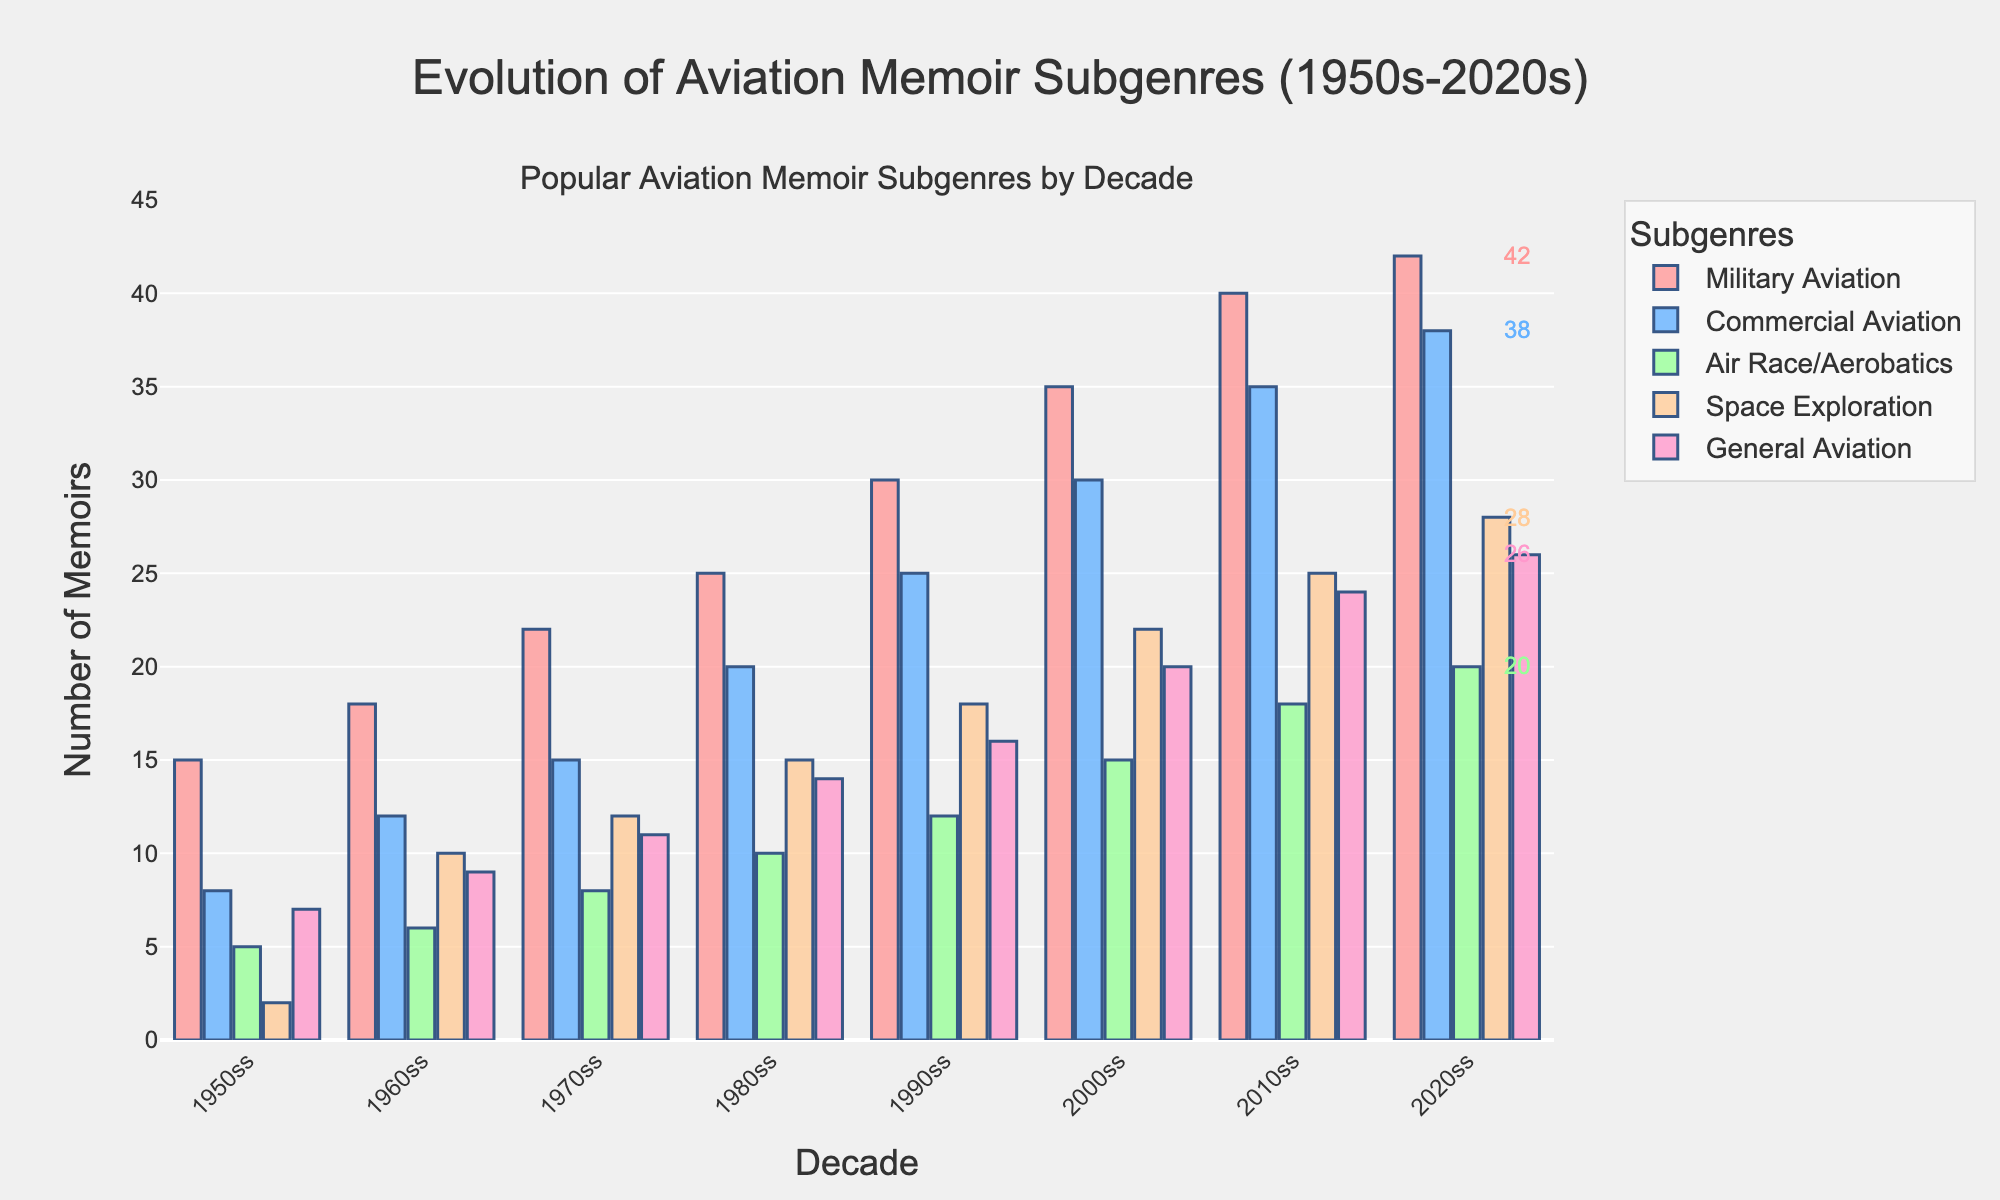What subgenre has the highest number of memoirs in the 2000s? Look at the bars for the 2000s and compare their heights. The tallest bar represents the subgenre with the highest number. Military Aviation has the tallest bar.
Answer: Military Aviation How did the number of commercial aviation memoirs change from the 1950s to the 2020s? Identify the bars for Commercial Aviation in the 1950s and 2020s. The number in the 1950s is 8, and in the 2020s is 38. Subtract the earlier value from the later value: 38 - 8 = 30.
Answer: Increased by 30 Which decade saw the highest increase in space exploration memoirs compared to the previous decade? Compare the number of space exploration memoirs in each decade. Calculate the difference between consecutive decades: 1960s (10-2=8), 1970s (12-10=2), 1980s (15-12=3), 1990s (18-15=3), 2000s (22-18=4), 2010s (25-22=3), 2020s (28-25=3). The highest increase is 8 between the 1950s and 1960s.
Answer: 1960s What is the total number of general aviation memoirs published across all decades? Sum the values for General Aviation across all decades: 7 + 9 + 11 + 14 + 16 + 20 + 24 + 26. The total is 127.
Answer: 127 By how much did the number of air race/aerobatics memoirs increase from the 1980s to the 2010s? Find the number of air race/aerobatics memoirs in the 1980s and 2010s. In the 1980s, there are 10, and in the 2010s, there are 18. Subtract the earlier value from the later value: 18 - 10 = 8.
Answer: Increased by 8 How many more military aviation memoirs were published in the 1990s compared to the 1960s? Identify the values for Military Aviation in the 1990s and 1960s. In the 1990s, there are 30 memoirs, and in the 1960s, there are 18. Subtract the 1960s value from the 1990s value: 30 - 18 = 12.
Answer: 12 more Which subgenre had the least growth from the 1970s to the 1980s? Calculate the growth for each subgenre from the 1970s to the 1980s: Military Aviation (25-22=3), Commercial Aviation (20-15=5), Air Race/Aerobatics (10-8=2), Space Exploration (15-12=3), General Aviation (14-11=3). The least growth is for Air Race/Aerobatics with 2.
Answer: Air Race/Aerobatics Between which two decades did commercial aviation memoirs see the largest increase in numbers? Compare the increase in Commercial Aviation memoirs between consecutive decades: 1960s (12-8=4), 1970s (15-12=3), 1980s (20-15=5), 1990s (25-20=5), 2000s (30-25=5), 2010s (35-30=5), 2020s (38-35=3). The largest increases are 5, occurring in several intervals (1980s-1990s, 1990s-2000s, 2000s-2010s).
Answer: 1980s to 2010s What is the average number of memoirs published in each subgenre in the 1980s? Sum the number of memoirs published in each subgenre in the 1980s and divide by the number of subgenres: (25+20+10+15+14)/5 = 84/5 = 16.8.
Answer: 16.8 Which subgenres have consistently increased in the number of memoirs published every decade? Check each subgenre for a consistent increase in numbers from one decade to the next. Military Aviation, Commercial Aviation, Space Exploration, and General Aviation show a consistent increase.
Answer: Military Aviation, Commercial Aviation, Space Exploration, General Aviation 